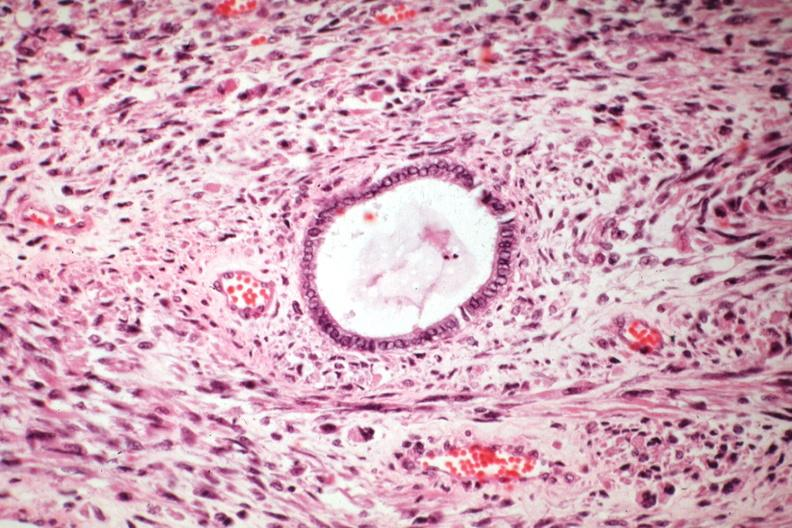s uterus present?
Answer the question using a single word or phrase. Yes 